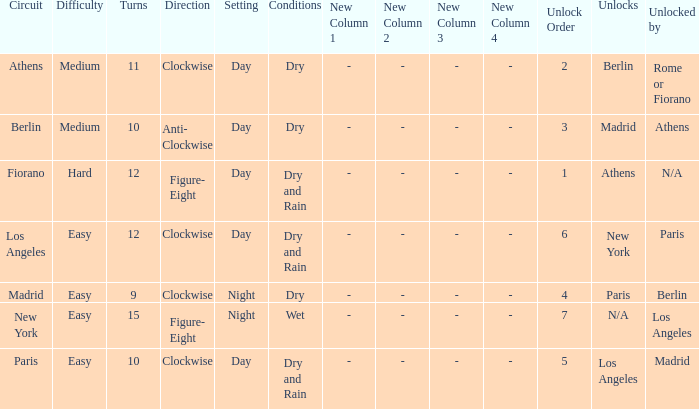What are the conditions for the athens circuit? Dry. 